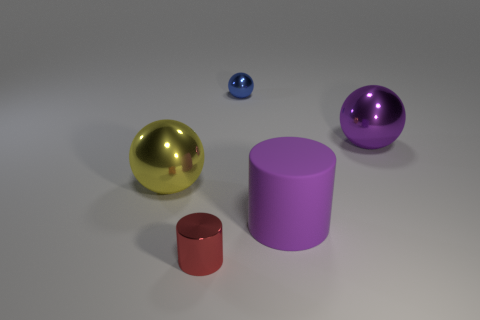Subtract all purple balls. How many balls are left? 2 Add 1 small cyan shiny balls. How many objects exist? 6 Subtract all purple spheres. How many spheres are left? 2 Subtract all spheres. How many objects are left? 2 Subtract 1 cylinders. How many cylinders are left? 1 Subtract all brown cylinders. Subtract all yellow balls. How many cylinders are left? 2 Subtract all red balls. How many blue cylinders are left? 0 Subtract all large gray balls. Subtract all blue things. How many objects are left? 4 Add 1 large yellow spheres. How many large yellow spheres are left? 2 Add 5 blue balls. How many blue balls exist? 6 